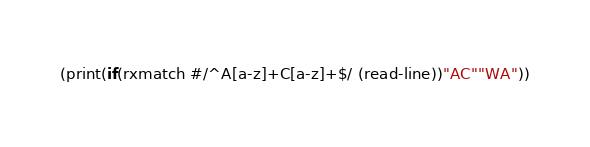<code> <loc_0><loc_0><loc_500><loc_500><_Scheme_>(print(if(rxmatch #/^A[a-z]+C[a-z]+$/ (read-line))"AC""WA"))</code> 